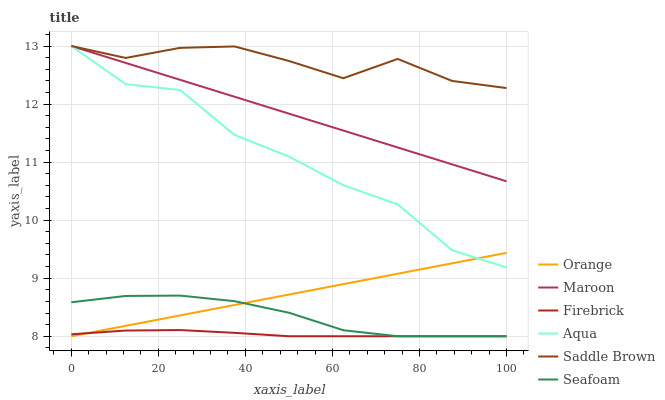Does Firebrick have the minimum area under the curve?
Answer yes or no. Yes. Does Saddle Brown have the maximum area under the curve?
Answer yes or no. Yes. Does Aqua have the minimum area under the curve?
Answer yes or no. No. Does Aqua have the maximum area under the curve?
Answer yes or no. No. Is Orange the smoothest?
Answer yes or no. Yes. Is Aqua the roughest?
Answer yes or no. Yes. Is Seafoam the smoothest?
Answer yes or no. No. Is Seafoam the roughest?
Answer yes or no. No. Does Firebrick have the lowest value?
Answer yes or no. Yes. Does Aqua have the lowest value?
Answer yes or no. No. Does Saddle Brown have the highest value?
Answer yes or no. Yes. Does Seafoam have the highest value?
Answer yes or no. No. Is Seafoam less than Maroon?
Answer yes or no. Yes. Is Saddle Brown greater than Seafoam?
Answer yes or no. Yes. Does Aqua intersect Orange?
Answer yes or no. Yes. Is Aqua less than Orange?
Answer yes or no. No. Is Aqua greater than Orange?
Answer yes or no. No. Does Seafoam intersect Maroon?
Answer yes or no. No. 